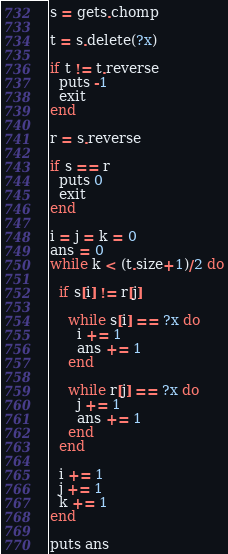Convert code to text. <code><loc_0><loc_0><loc_500><loc_500><_Ruby_>s = gets.chomp
 
t = s.delete(?x)
 
if t != t.reverse
  puts -1
  exit
end
 
r = s.reverse
 
if s == r
  puts 0
  exit
end
 
i = j = k = 0
ans = 0
while k < (t.size+1)/2 do
  
  if s[i] != r[j]
    
    while s[i] == ?x do
      i += 1
      ans += 1
    end
    
    while r[j] == ?x do
      j += 1
      ans += 1 
    end
  end
  
  i += 1
  j += 1
  k += 1
end
 
puts ans</code> 